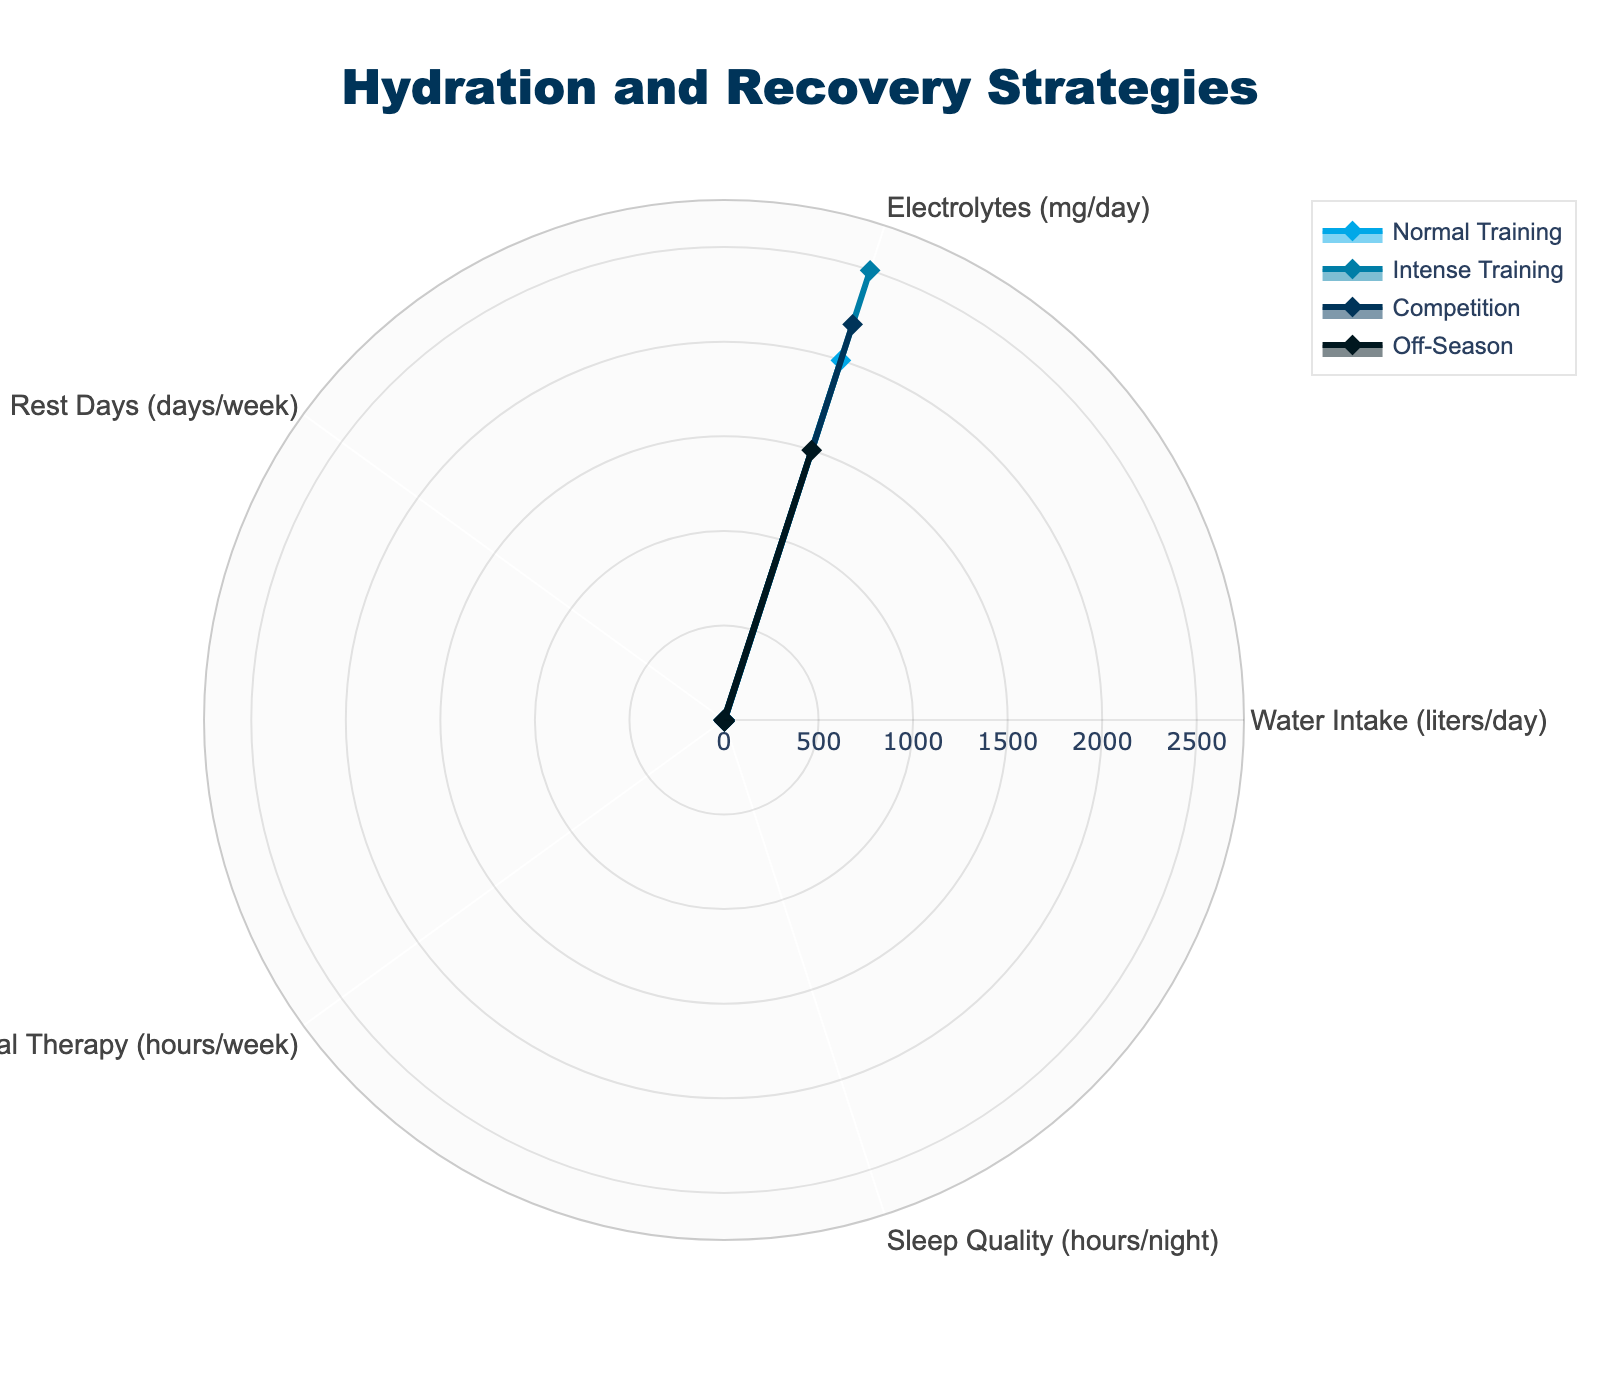What is the title of the radar chart? The title of the radar chart is written at the top of the figure.
Answer: Hydration and Recovery Strategies Which category shows the highest water intake? By looking at the values of water intake in the figure, the highest value can be identified.
Answer: Intense Training How many hours per week is spent on physical therapy during competition? Check the value of physical therapy for the competition category.
Answer: 2.5 Compare the sleep quality between Normal Training and Competition categories. Which one has higher values? Look at the sleep quality values for both categories and compare them.
Answer: Normal Training What is the difference in water intake between Normal Training and Competition? Subtract the water intake value of Competition from the water intake value of Normal Training.
Answer: 0.5 liters/day Which category has the lowest electrolytes intake? Identify the category with the smallest value for electrolytes.
Answer: Off-Season What is the average sleep quality across all categories? Add the sleep quality values for all categories and divide by the number of categories.
Answer: 7.75 hours/night How many more rest days are there during Off-Season compared to Intense Training? Subtract the number of rest days in Intense Training from the number of rest days in Off-Season.
Answer: 2 days/week Between Normal Training and Intense Training, which category has higher electrolytes intake? Compare the electrolytes intake values of Normal Training and Intense Training.
Answer: Intense Training Which category requires the least number of rest days per week? Identify the category with the smallest value for rest days.
Answer: Intense Training and Competition 